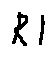Convert formula to latex. <formula><loc_0><loc_0><loc_500><loc_500>R 1</formula> 